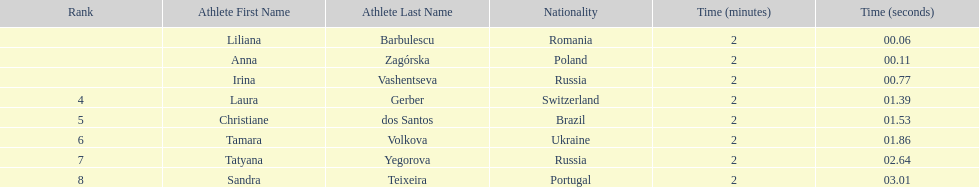In regards to anna zagorska, what was her finishing time? 2:00.11. 